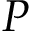<formula> <loc_0><loc_0><loc_500><loc_500>P</formula> 